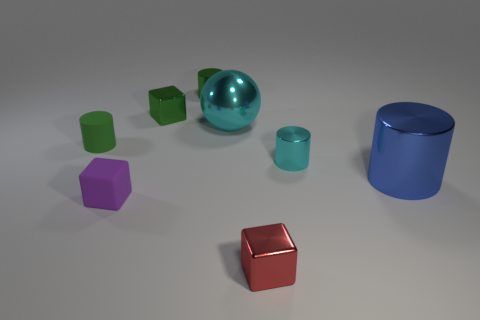How many other objects are there of the same color as the matte cylinder?
Your answer should be very brief. 2. What is the small red thing made of?
Provide a succinct answer. Metal. Does the red cube that is to the left of the cyan metal cylinder have the same size as the rubber cube?
Offer a very short reply. Yes. The cyan metallic thing that is the same shape as the large blue shiny object is what size?
Your response must be concise. Small. Are there the same number of things behind the small green metallic cylinder and small purple matte objects behind the red thing?
Make the answer very short. No. There is a cyan shiny thing right of the red metal block; what size is it?
Your response must be concise. Small. Are there any other things that are the same shape as the large cyan shiny thing?
Provide a succinct answer. No. Is the number of cyan metallic things to the right of the red block the same as the number of small cubes?
Give a very brief answer. No. There is a blue object; are there any metallic cubes to the right of it?
Offer a very short reply. No. There is a purple rubber object; does it have the same shape as the small rubber thing behind the purple matte block?
Make the answer very short. No. 